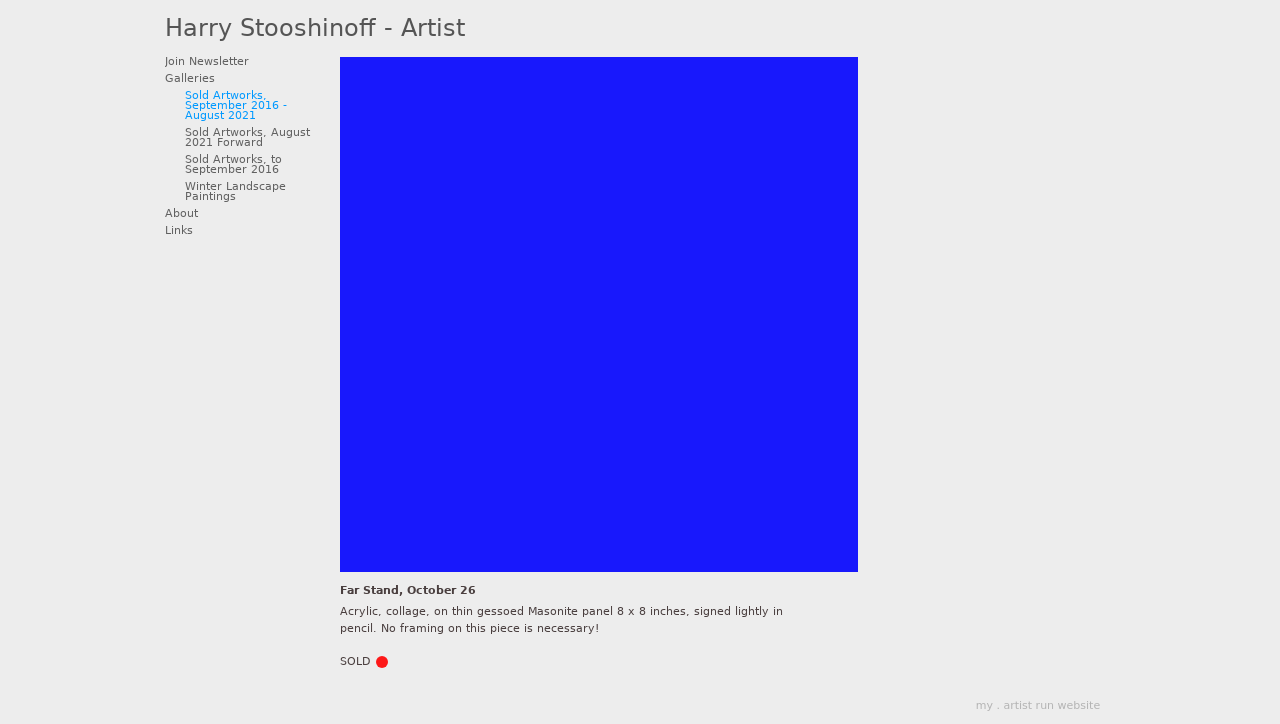What's the procedure for constructing this website from scratch with HTML? To construct a website like the one shown in the image from scratch using HTML, start by defining the structure of your webpage with HTML elements. Create a basic HTML document with 'doctype' declaration and define the 'html' element with 'head' and 'body' sections. Use 'div' tags to create sections for the header, content, and footer. Utilize 'ul' and 'li' for navigation menus. Apply CSS for styling to ensure the website is visually appealing. Don't forget to test on various devices for responsiveness, and validate your HTML to ensure cross-browser compatibility. 